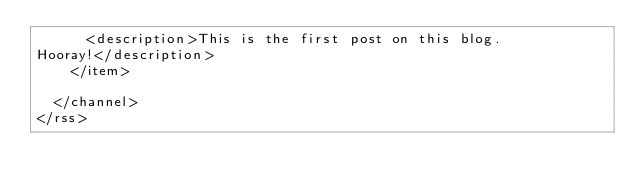<code> <loc_0><loc_0><loc_500><loc_500><_XML_>      <description>This is the first post on this blog.
Hooray!</description>
    </item>
    
  </channel>
</rss>
</code> 